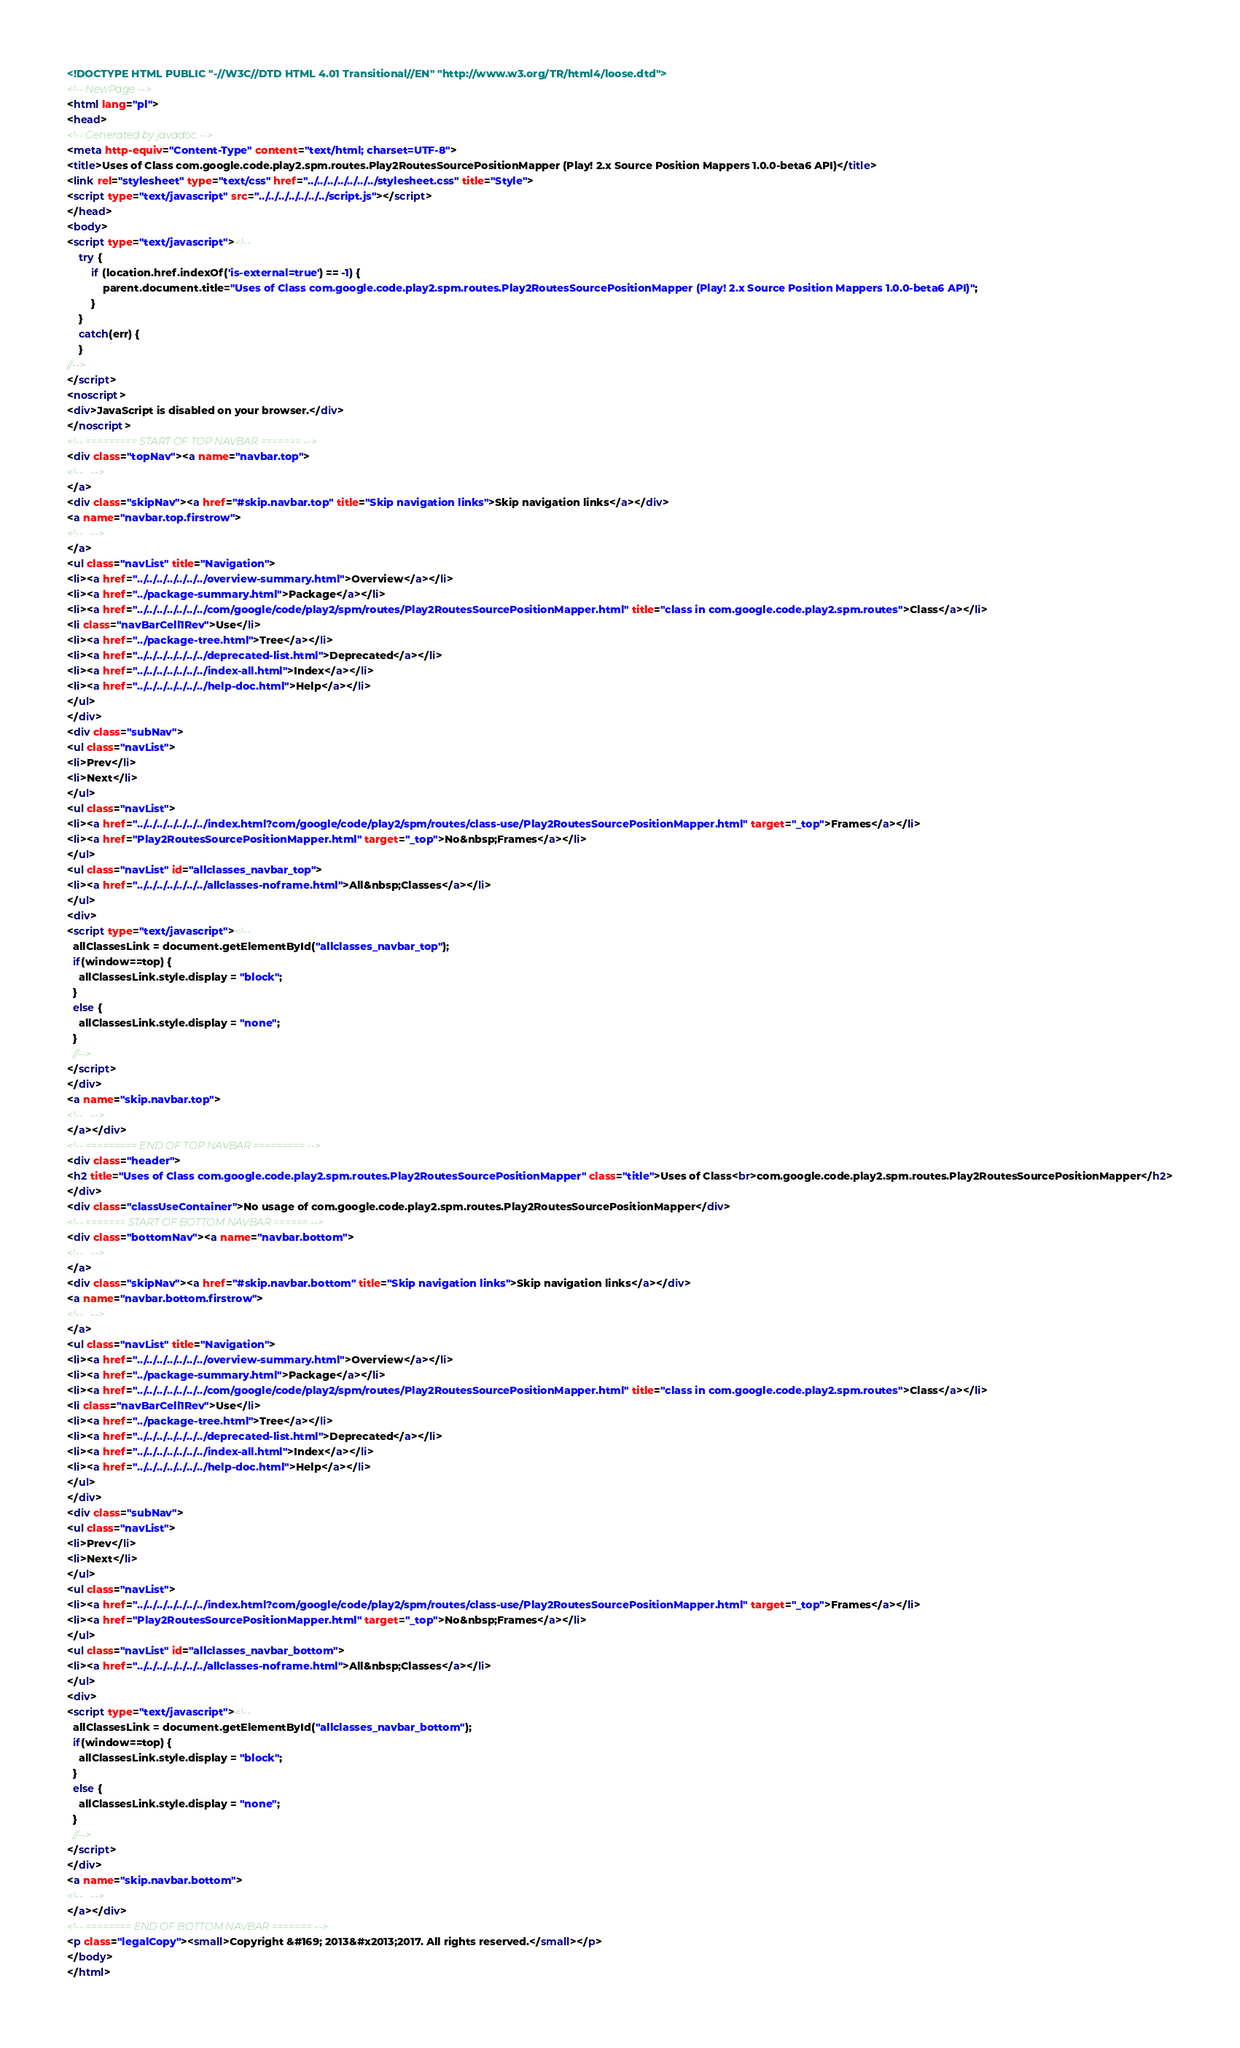<code> <loc_0><loc_0><loc_500><loc_500><_HTML_><!DOCTYPE HTML PUBLIC "-//W3C//DTD HTML 4.01 Transitional//EN" "http://www.w3.org/TR/html4/loose.dtd">
<!-- NewPage -->
<html lang="pl">
<head>
<!-- Generated by javadoc -->
<meta http-equiv="Content-Type" content="text/html; charset=UTF-8">
<title>Uses of Class com.google.code.play2.spm.routes.Play2RoutesSourcePositionMapper (Play! 2.x Source Position Mappers 1.0.0-beta6 API)</title>
<link rel="stylesheet" type="text/css" href="../../../../../../../stylesheet.css" title="Style">
<script type="text/javascript" src="../../../../../../../script.js"></script>
</head>
<body>
<script type="text/javascript"><!--
    try {
        if (location.href.indexOf('is-external=true') == -1) {
            parent.document.title="Uses of Class com.google.code.play2.spm.routes.Play2RoutesSourcePositionMapper (Play! 2.x Source Position Mappers 1.0.0-beta6 API)";
        }
    }
    catch(err) {
    }
//-->
</script>
<noscript>
<div>JavaScript is disabled on your browser.</div>
</noscript>
<!-- ========= START OF TOP NAVBAR ======= -->
<div class="topNav"><a name="navbar.top">
<!--   -->
</a>
<div class="skipNav"><a href="#skip.navbar.top" title="Skip navigation links">Skip navigation links</a></div>
<a name="navbar.top.firstrow">
<!--   -->
</a>
<ul class="navList" title="Navigation">
<li><a href="../../../../../../../overview-summary.html">Overview</a></li>
<li><a href="../package-summary.html">Package</a></li>
<li><a href="../../../../../../../com/google/code/play2/spm/routes/Play2RoutesSourcePositionMapper.html" title="class in com.google.code.play2.spm.routes">Class</a></li>
<li class="navBarCell1Rev">Use</li>
<li><a href="../package-tree.html">Tree</a></li>
<li><a href="../../../../../../../deprecated-list.html">Deprecated</a></li>
<li><a href="../../../../../../../index-all.html">Index</a></li>
<li><a href="../../../../../../../help-doc.html">Help</a></li>
</ul>
</div>
<div class="subNav">
<ul class="navList">
<li>Prev</li>
<li>Next</li>
</ul>
<ul class="navList">
<li><a href="../../../../../../../index.html?com/google/code/play2/spm/routes/class-use/Play2RoutesSourcePositionMapper.html" target="_top">Frames</a></li>
<li><a href="Play2RoutesSourcePositionMapper.html" target="_top">No&nbsp;Frames</a></li>
</ul>
<ul class="navList" id="allclasses_navbar_top">
<li><a href="../../../../../../../allclasses-noframe.html">All&nbsp;Classes</a></li>
</ul>
<div>
<script type="text/javascript"><!--
  allClassesLink = document.getElementById("allclasses_navbar_top");
  if(window==top) {
    allClassesLink.style.display = "block";
  }
  else {
    allClassesLink.style.display = "none";
  }
  //-->
</script>
</div>
<a name="skip.navbar.top">
<!--   -->
</a></div>
<!-- ========= END OF TOP NAVBAR ========= -->
<div class="header">
<h2 title="Uses of Class com.google.code.play2.spm.routes.Play2RoutesSourcePositionMapper" class="title">Uses of Class<br>com.google.code.play2.spm.routes.Play2RoutesSourcePositionMapper</h2>
</div>
<div class="classUseContainer">No usage of com.google.code.play2.spm.routes.Play2RoutesSourcePositionMapper</div>
<!-- ======= START OF BOTTOM NAVBAR ====== -->
<div class="bottomNav"><a name="navbar.bottom">
<!--   -->
</a>
<div class="skipNav"><a href="#skip.navbar.bottom" title="Skip navigation links">Skip navigation links</a></div>
<a name="navbar.bottom.firstrow">
<!--   -->
</a>
<ul class="navList" title="Navigation">
<li><a href="../../../../../../../overview-summary.html">Overview</a></li>
<li><a href="../package-summary.html">Package</a></li>
<li><a href="../../../../../../../com/google/code/play2/spm/routes/Play2RoutesSourcePositionMapper.html" title="class in com.google.code.play2.spm.routes">Class</a></li>
<li class="navBarCell1Rev">Use</li>
<li><a href="../package-tree.html">Tree</a></li>
<li><a href="../../../../../../../deprecated-list.html">Deprecated</a></li>
<li><a href="../../../../../../../index-all.html">Index</a></li>
<li><a href="../../../../../../../help-doc.html">Help</a></li>
</ul>
</div>
<div class="subNav">
<ul class="navList">
<li>Prev</li>
<li>Next</li>
</ul>
<ul class="navList">
<li><a href="../../../../../../../index.html?com/google/code/play2/spm/routes/class-use/Play2RoutesSourcePositionMapper.html" target="_top">Frames</a></li>
<li><a href="Play2RoutesSourcePositionMapper.html" target="_top">No&nbsp;Frames</a></li>
</ul>
<ul class="navList" id="allclasses_navbar_bottom">
<li><a href="../../../../../../../allclasses-noframe.html">All&nbsp;Classes</a></li>
</ul>
<div>
<script type="text/javascript"><!--
  allClassesLink = document.getElementById("allclasses_navbar_bottom");
  if(window==top) {
    allClassesLink.style.display = "block";
  }
  else {
    allClassesLink.style.display = "none";
  }
  //-->
</script>
</div>
<a name="skip.navbar.bottom">
<!--   -->
</a></div>
<!-- ======== END OF BOTTOM NAVBAR ======= -->
<p class="legalCopy"><small>Copyright &#169; 2013&#x2013;2017. All rights reserved.</small></p>
</body>
</html>
</code> 